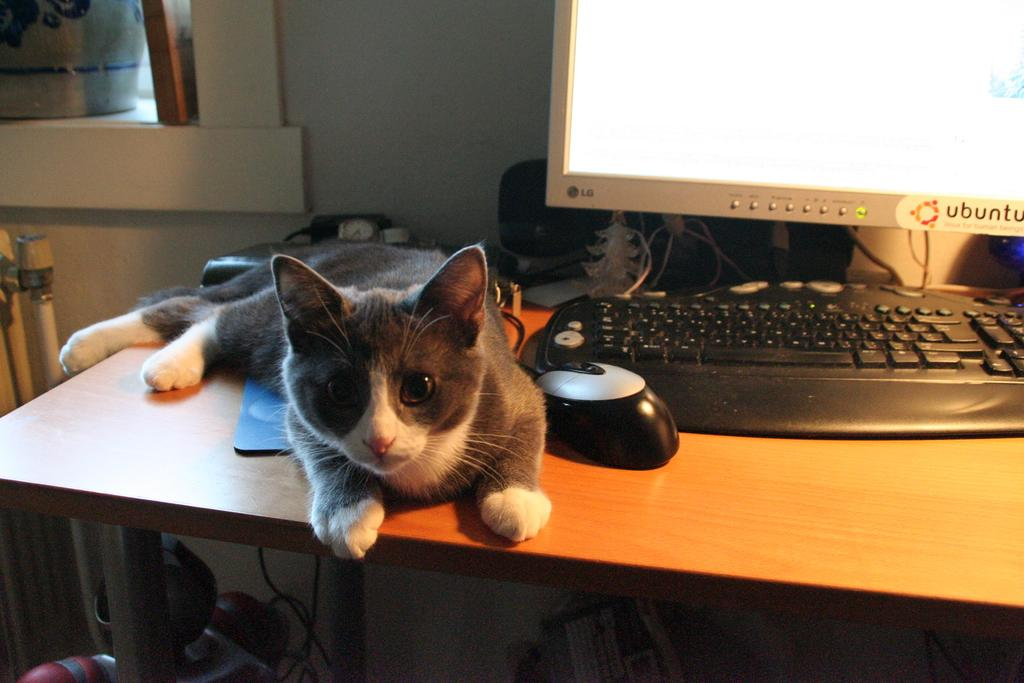What type of animal is on the table in the image? There is a cat on the table in the image. What electronic device is visible in the image? There is a monitor in the image. What is used for input with the computer in the image? There is a keyboard in the image. What is used for pointing and clicking on the monitor in the image? There is a mouse (likely a computer mouse) in the image. How many women are present in the image? There is no information about women in the image; it only mentions a cat, monitor, keyboard, and mouse. 